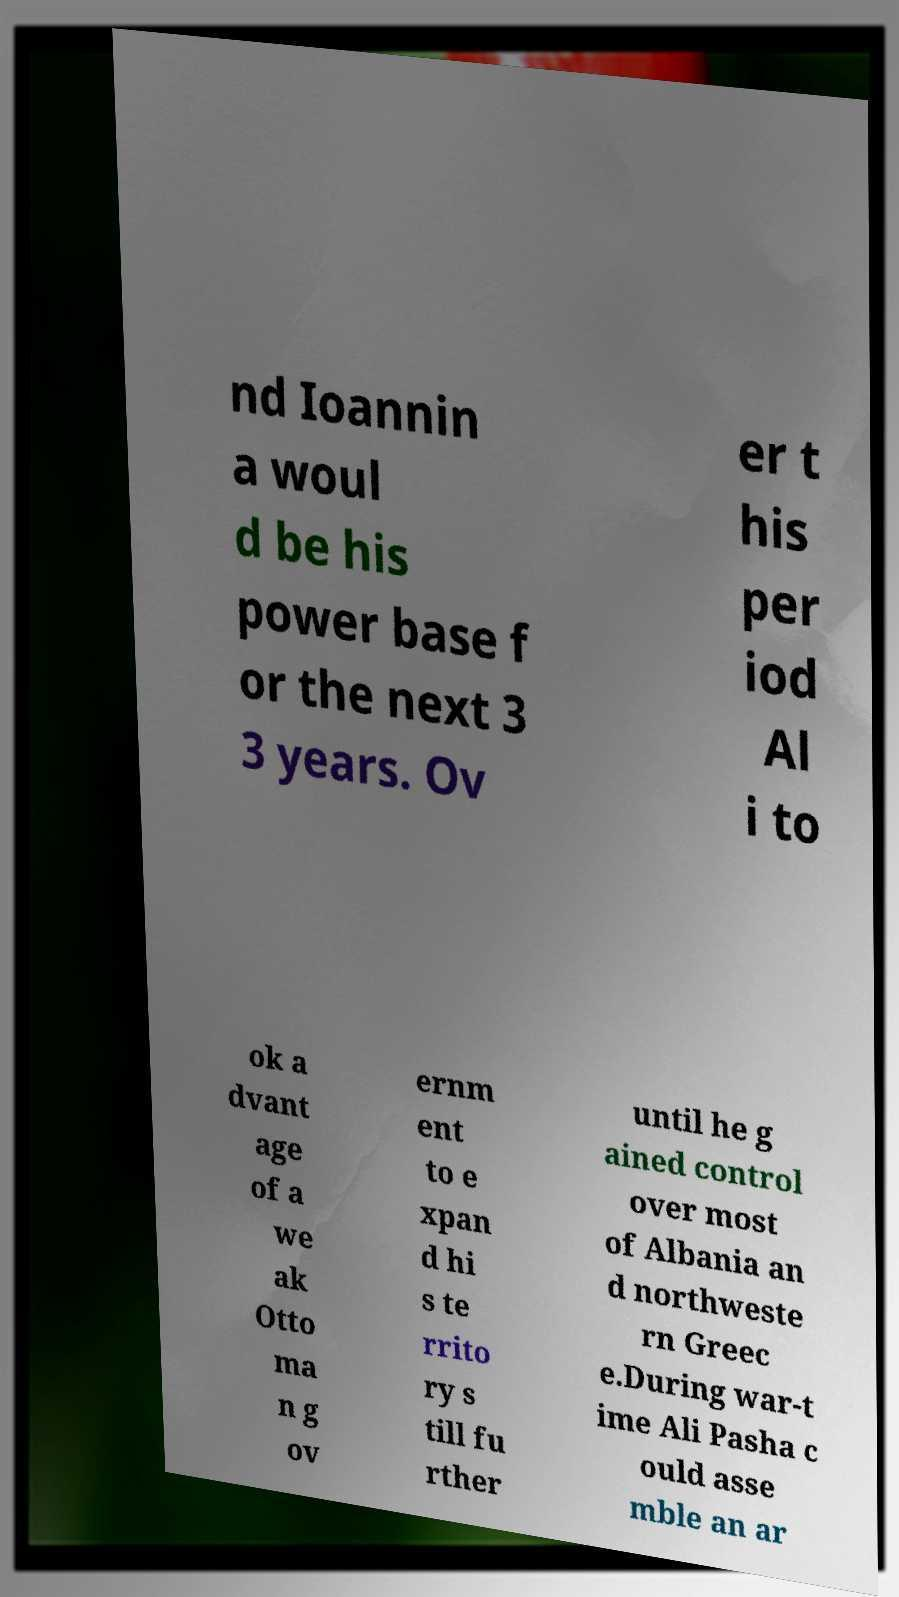What messages or text are displayed in this image? I need them in a readable, typed format. nd Ioannin a woul d be his power base f or the next 3 3 years. Ov er t his per iod Al i to ok a dvant age of a we ak Otto ma n g ov ernm ent to e xpan d hi s te rrito ry s till fu rther until he g ained control over most of Albania an d northweste rn Greec e.During war-t ime Ali Pasha c ould asse mble an ar 